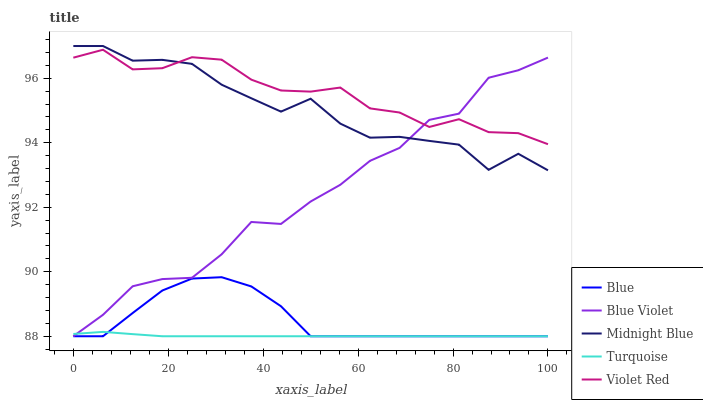Does Turquoise have the minimum area under the curve?
Answer yes or no. Yes. Does Violet Red have the maximum area under the curve?
Answer yes or no. Yes. Does Violet Red have the minimum area under the curve?
Answer yes or no. No. Does Turquoise have the maximum area under the curve?
Answer yes or no. No. Is Turquoise the smoothest?
Answer yes or no. Yes. Is Midnight Blue the roughest?
Answer yes or no. Yes. Is Violet Red the smoothest?
Answer yes or no. No. Is Violet Red the roughest?
Answer yes or no. No. Does Blue have the lowest value?
Answer yes or no. Yes. Does Violet Red have the lowest value?
Answer yes or no. No. Does Midnight Blue have the highest value?
Answer yes or no. Yes. Does Violet Red have the highest value?
Answer yes or no. No. Is Turquoise less than Violet Red?
Answer yes or no. Yes. Is Violet Red greater than Blue?
Answer yes or no. Yes. Does Midnight Blue intersect Violet Red?
Answer yes or no. Yes. Is Midnight Blue less than Violet Red?
Answer yes or no. No. Is Midnight Blue greater than Violet Red?
Answer yes or no. No. Does Turquoise intersect Violet Red?
Answer yes or no. No. 